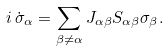Convert formula to latex. <formula><loc_0><loc_0><loc_500><loc_500>i \, \dot { \sigma } _ { \alpha } = \sum _ { \beta \neq \alpha } J _ { \alpha \beta } S _ { \alpha \beta } \sigma _ { \beta } .</formula> 